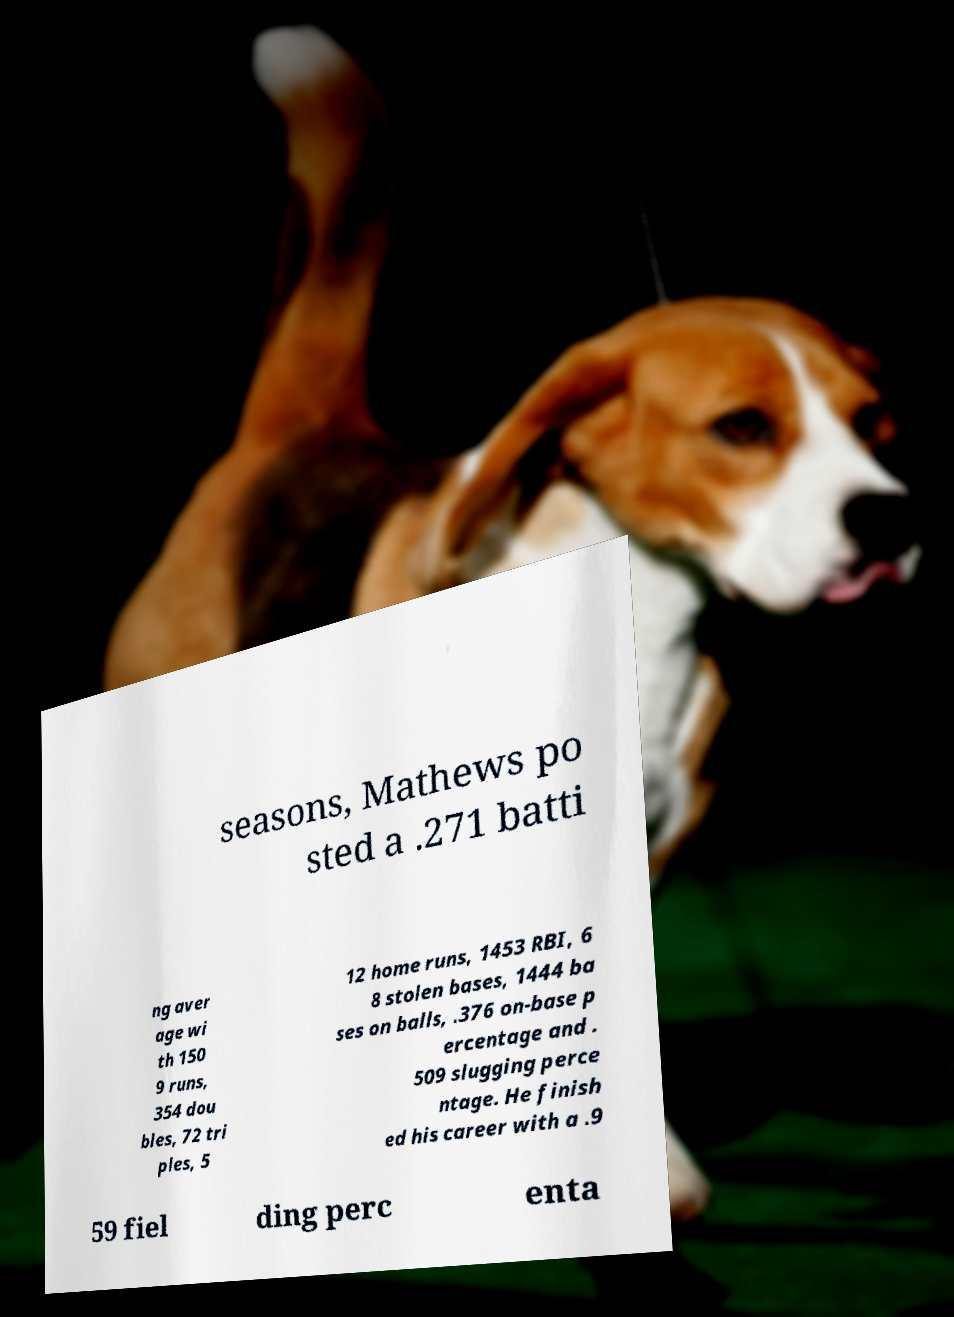There's text embedded in this image that I need extracted. Can you transcribe it verbatim? seasons, Mathews po sted a .271 batti ng aver age wi th 150 9 runs, 354 dou bles, 72 tri ples, 5 12 home runs, 1453 RBI, 6 8 stolen bases, 1444 ba ses on balls, .376 on-base p ercentage and . 509 slugging perce ntage. He finish ed his career with a .9 59 fiel ding perc enta 